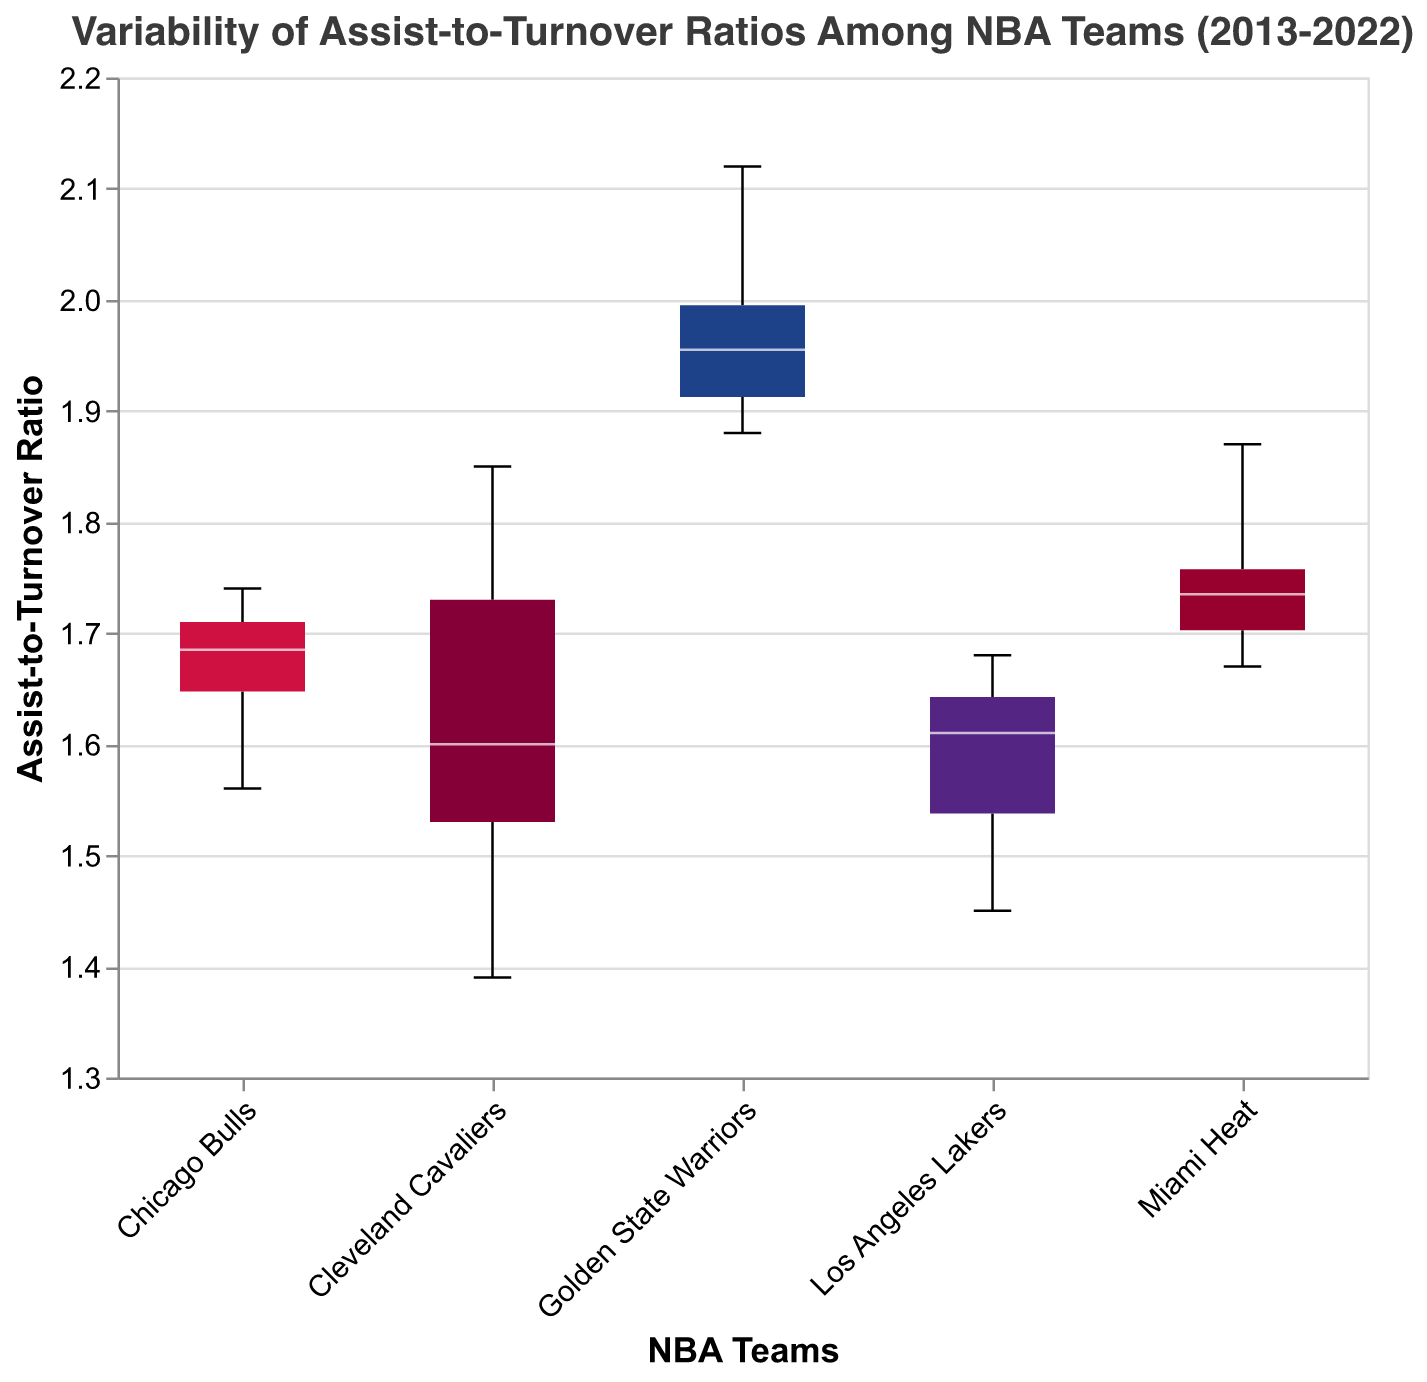What is the title of the plot? The title is displayed at the top of the plot. It states the main subject of the visualization, which indicates the variability of assist-to-turnover ratios among NBA teams over a specific period.
Answer: Variability of Assist-to-Turnover Ratios Among NBA Teams (2013-2022) What range of assist-to-turnover ratio is displayed on the y-axis? The y-axis shows the scale of assist-to-turnover ratios with specific bounds on its domain. This can be interpreted directly from the axis labels.
Answer: 1.3 to 2.2 Which team has the highest median assist-to-turnover ratio? To find this, we look at the median lines within the boxes of the notched box plot, which represents the median values for each team.
Answer: Golden State Warriors Which team has the lowest range in their assist-to-turnover ratios? The range of assist-to-turnover ratios for each team is represented by the length of the box in their respective box plot. The shortest box represents the team with the smallest range.
Answer: Golden State Warriors Which NBA team exhibits the most variability in assist-to-turnover ratios? Variability is represented by the overall height of the box and the extent of the whiskers beyond the box in a box plot. The team with the largest box and longest whiskers depicts the most variability.
Answer: Los Angeles Lakers What is the interquartile range (IQR) for the Miami Heat's assist-to-turnover ratios? The IQR is the range between the first quartile (bottom of the box) and the third quartile (top of the box). You observe where these positions are for the Miami Heat in the notched box plot.
Answer: Approx. 1.70 - 1.76 Which team's assist-to-turnover ratios intersect with the notches of another team's box plot the most? In a notched box plot, notches indicate the approximate confidence interval around the median. To find intersections, we compare notches across different teams to see which ones overlap.
Answer: Chicago Bulls Across which years are the data points being plotted? The x-axis typically does not directly display years in this specific plot, but the title and underlying data indicate the span of the dataset. These insights are derived from the title's summary and data description.
Answer: 2013 - 2022 Does any team have outliers in their assist-to-turnover ratios? Outliers in a box plot are indicated by points outside the whiskers. By checking the plot closely, you can identify if any team has such outlying points.
Answer: No outliers Which team shows a consistent upward trend in assist-to-turnover ratios over the years? To identify a trend over time, you compare the box plots' median value positions across multiple years notably. However, the consistent upward trend for a single team isn’t directly evident in a box plot. Yet, we can track the relative consistency of teams visually here.
Answer: None (direct consistent trend isn't clearly shown) 